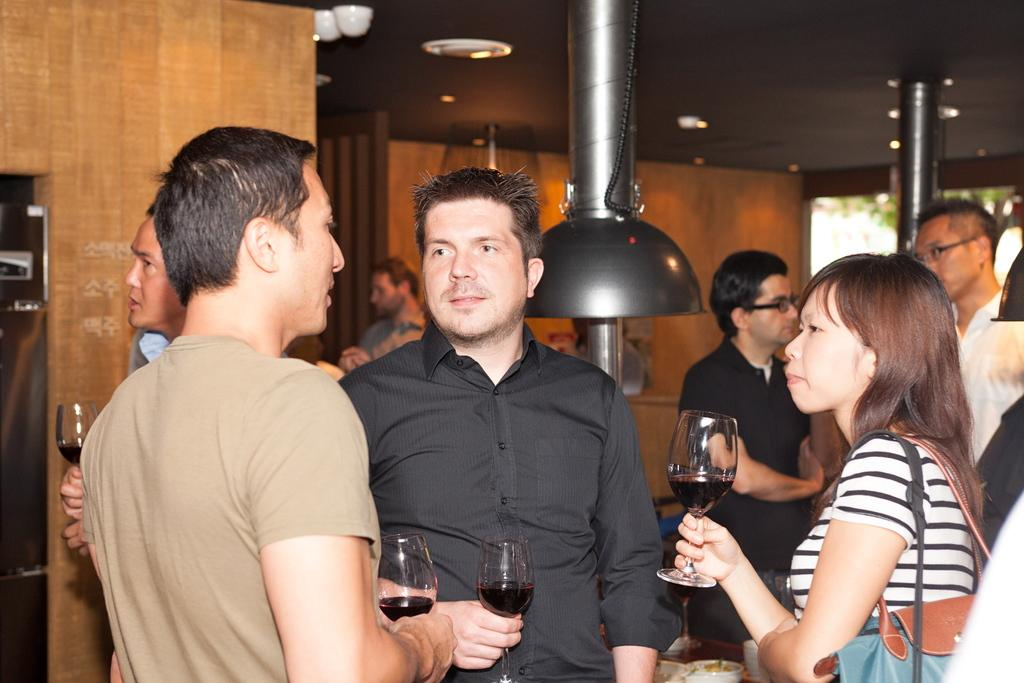What is happening in the image involving a group of people? There is a group of people in the image, and they are standing. What are the people holding in the image? The people are holding wine glasses in the image. What can be seen in the background of the image? There are windows and trees visible in the background of the image. How many waves can be seen crashing against the shore in the image? There are no waves or shore visible in the image; it features a group of people standing and holding wine glasses. What type of paper is being used by the people in the image? There is no paper present in the image; the people are holding wine glasses. 